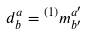<formula> <loc_0><loc_0><loc_500><loc_500>d ^ { a } _ { b } = { ^ { ( 1 ) } m ^ { a ^ { \prime } } _ { b ^ { \prime } } }</formula> 